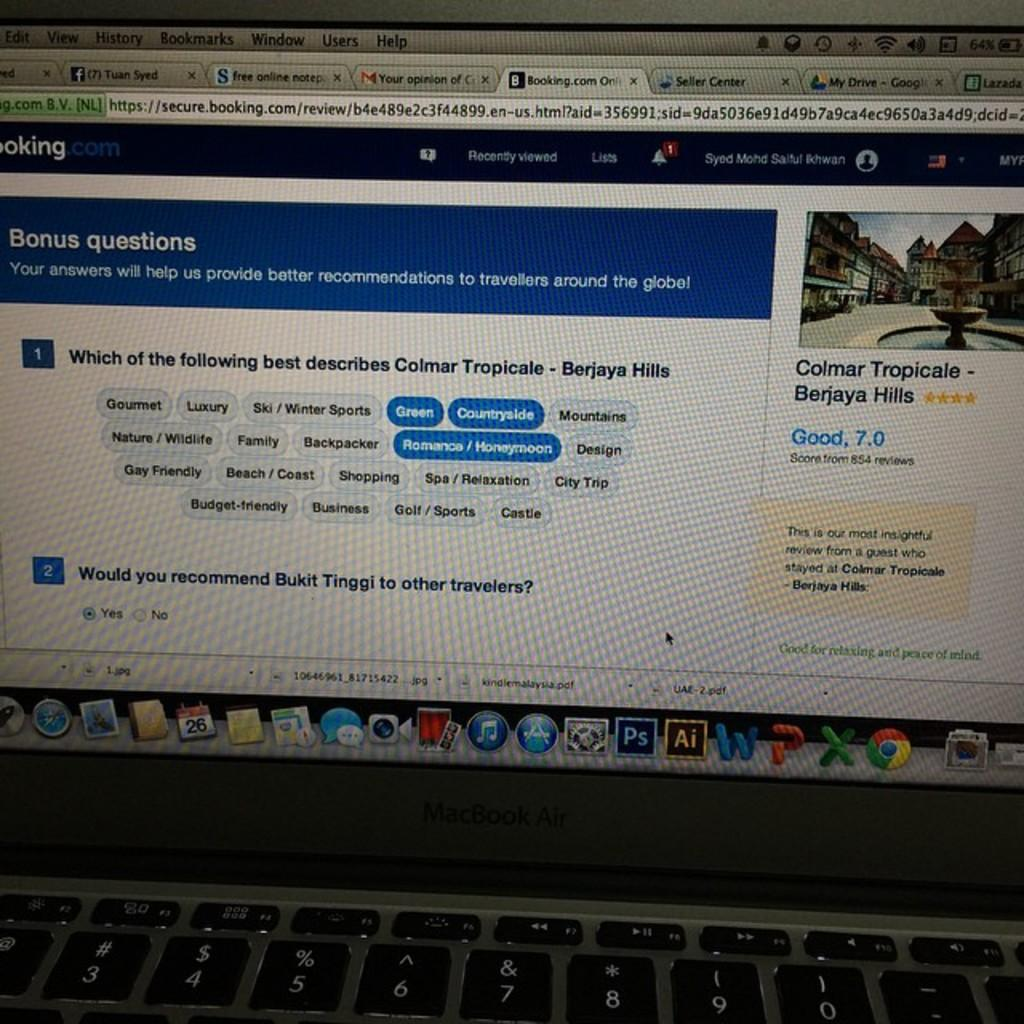<image>
Write a terse but informative summary of the picture. A Macbook Air is opened to a booking.com web page. 